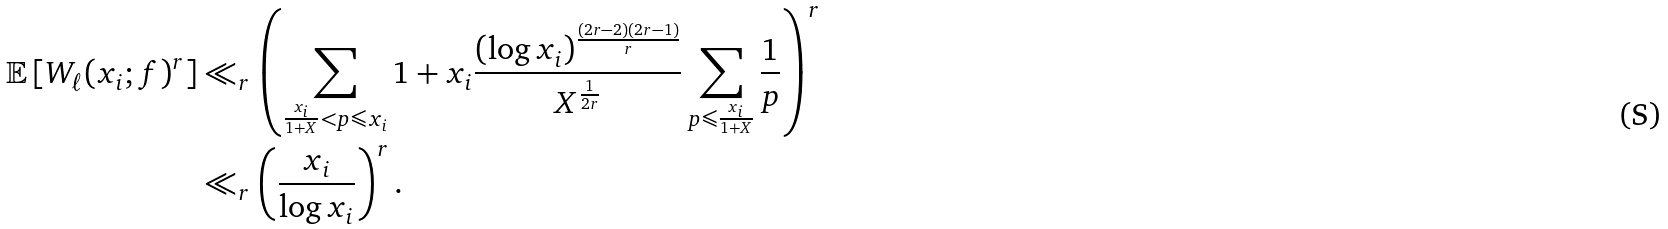<formula> <loc_0><loc_0><loc_500><loc_500>\mathbb { E } \left [ W _ { \ell } ( x _ { i } ; f ) ^ { r } \right ] & \ll _ { r } \left ( \sum _ { \frac { x _ { i } } { 1 + X } < p \leqslant x _ { i } } 1 + x _ { i } \frac { ( \log x _ { i } ) ^ { \frac { ( 2 r - 2 ) ( 2 r - 1 ) } { r } } } { X ^ { \frac { 1 } { 2 r } } } \sum _ { p \leqslant \frac { x _ { i } } { 1 + X } } \frac { 1 } { p } \right ) ^ { r } \\ & \ll _ { r } \left ( \frac { x _ { i } } { \log x _ { i } } \right ) ^ { r } .</formula> 